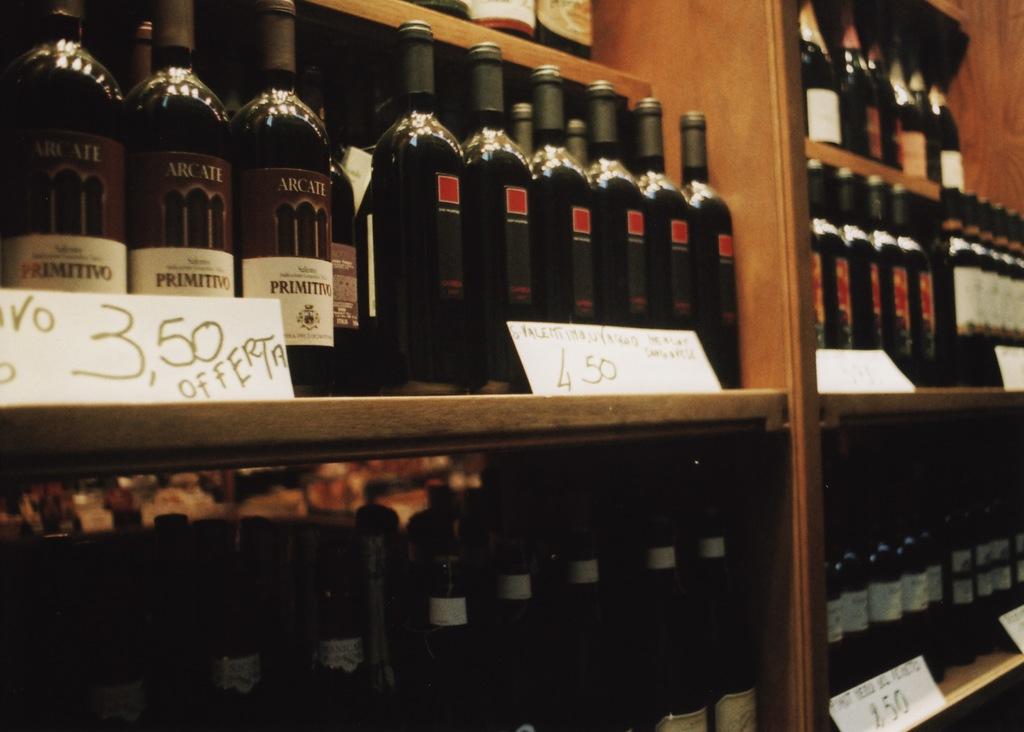What is the name of the brand of the alcohol bottles to the left?
Ensure brevity in your answer.  Primitivo. 